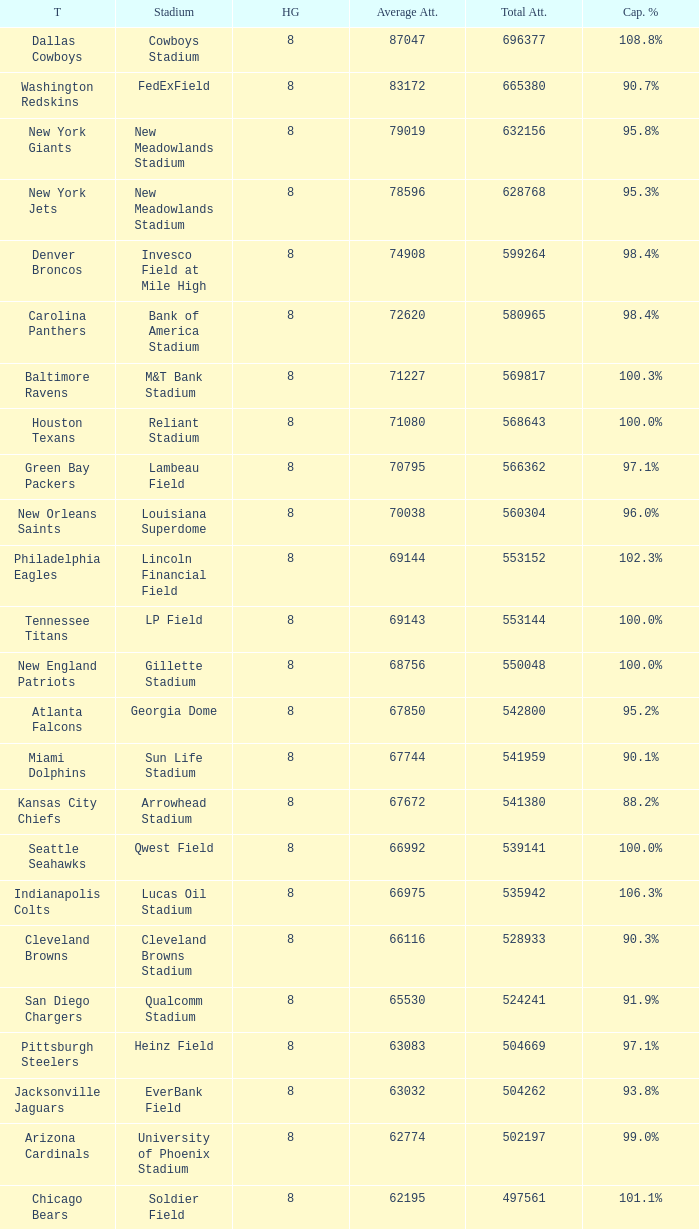What was the capacity for the Denver Broncos? 98.4%. 